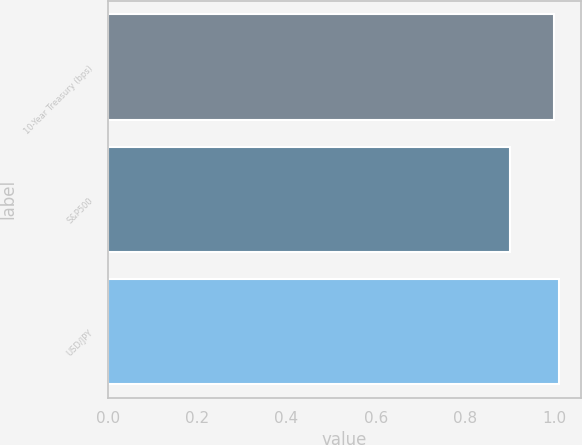Convert chart to OTSL. <chart><loc_0><loc_0><loc_500><loc_500><bar_chart><fcel>10-Year Treasury (bps)<fcel>S&P500<fcel>USD/JPY<nl><fcel>1<fcel>0.9<fcel>1.01<nl></chart> 